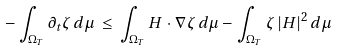Convert formula to latex. <formula><loc_0><loc_0><loc_500><loc_500>- \int _ { \Omega _ { T } } \partial _ { t } \zeta \, d \mu \, \leq \, \int _ { \Omega _ { T } } H \cdot \nabla \zeta \, d \mu - \int _ { \Omega _ { T } } \zeta \, | H | ^ { 2 } \, d \mu</formula> 